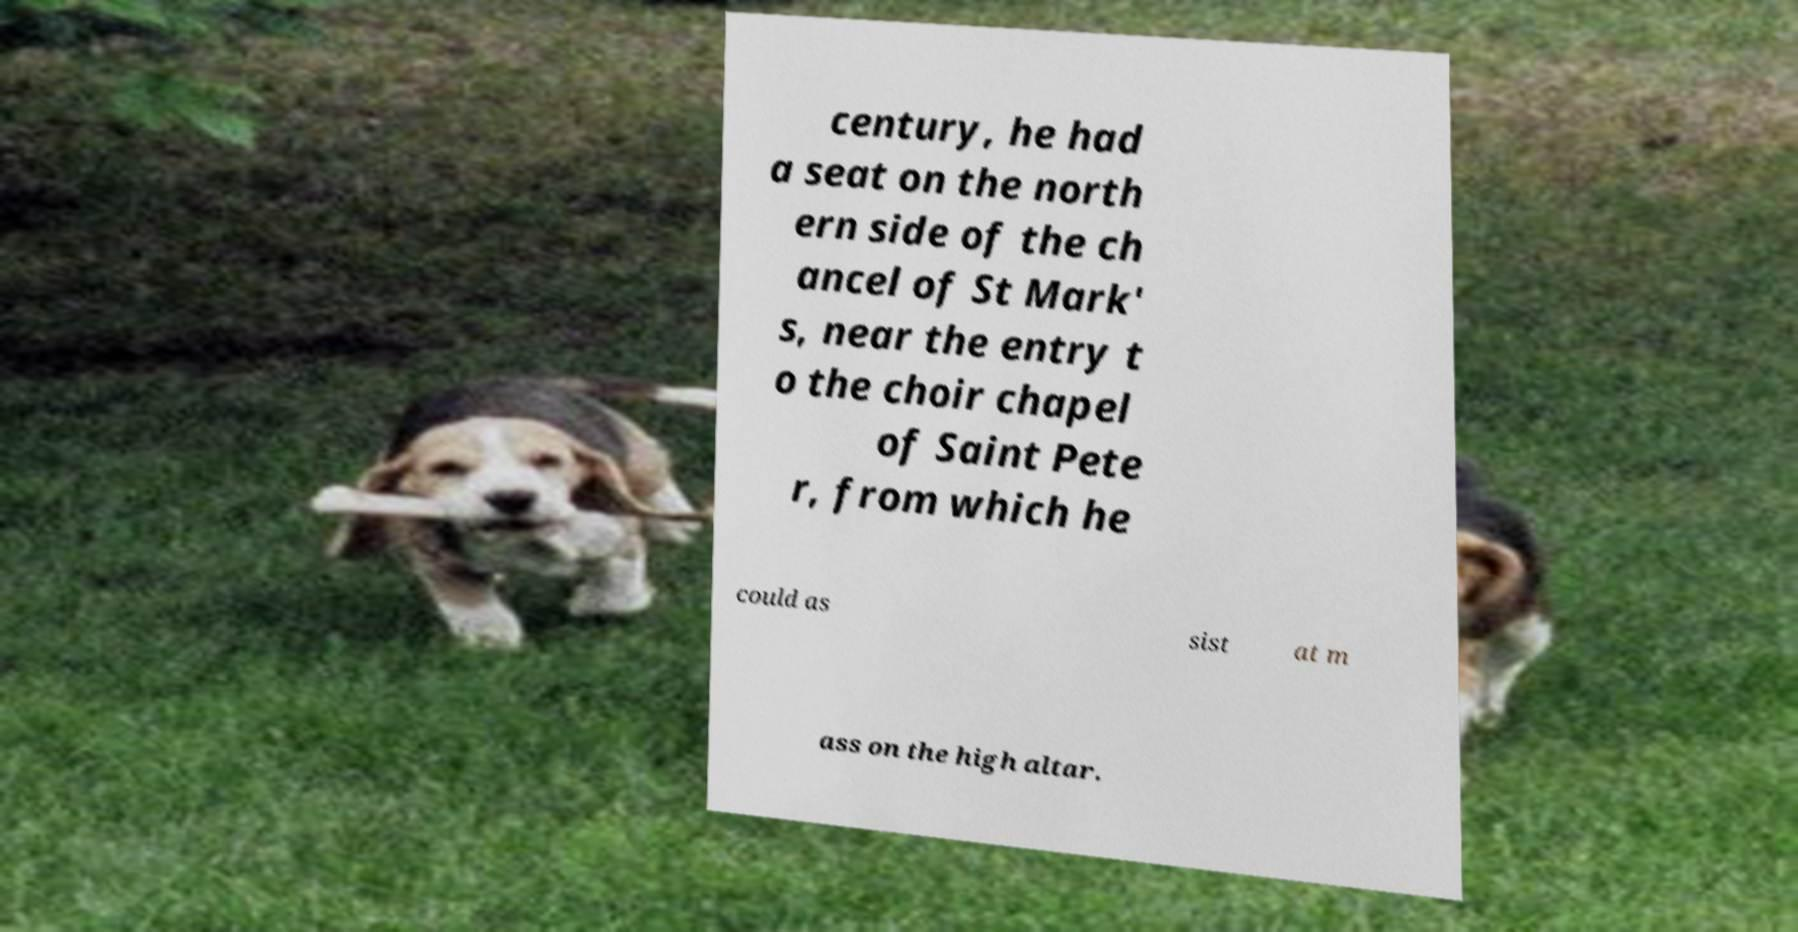Could you extract and type out the text from this image? century, he had a seat on the north ern side of the ch ancel of St Mark' s, near the entry t o the choir chapel of Saint Pete r, from which he could as sist at m ass on the high altar. 